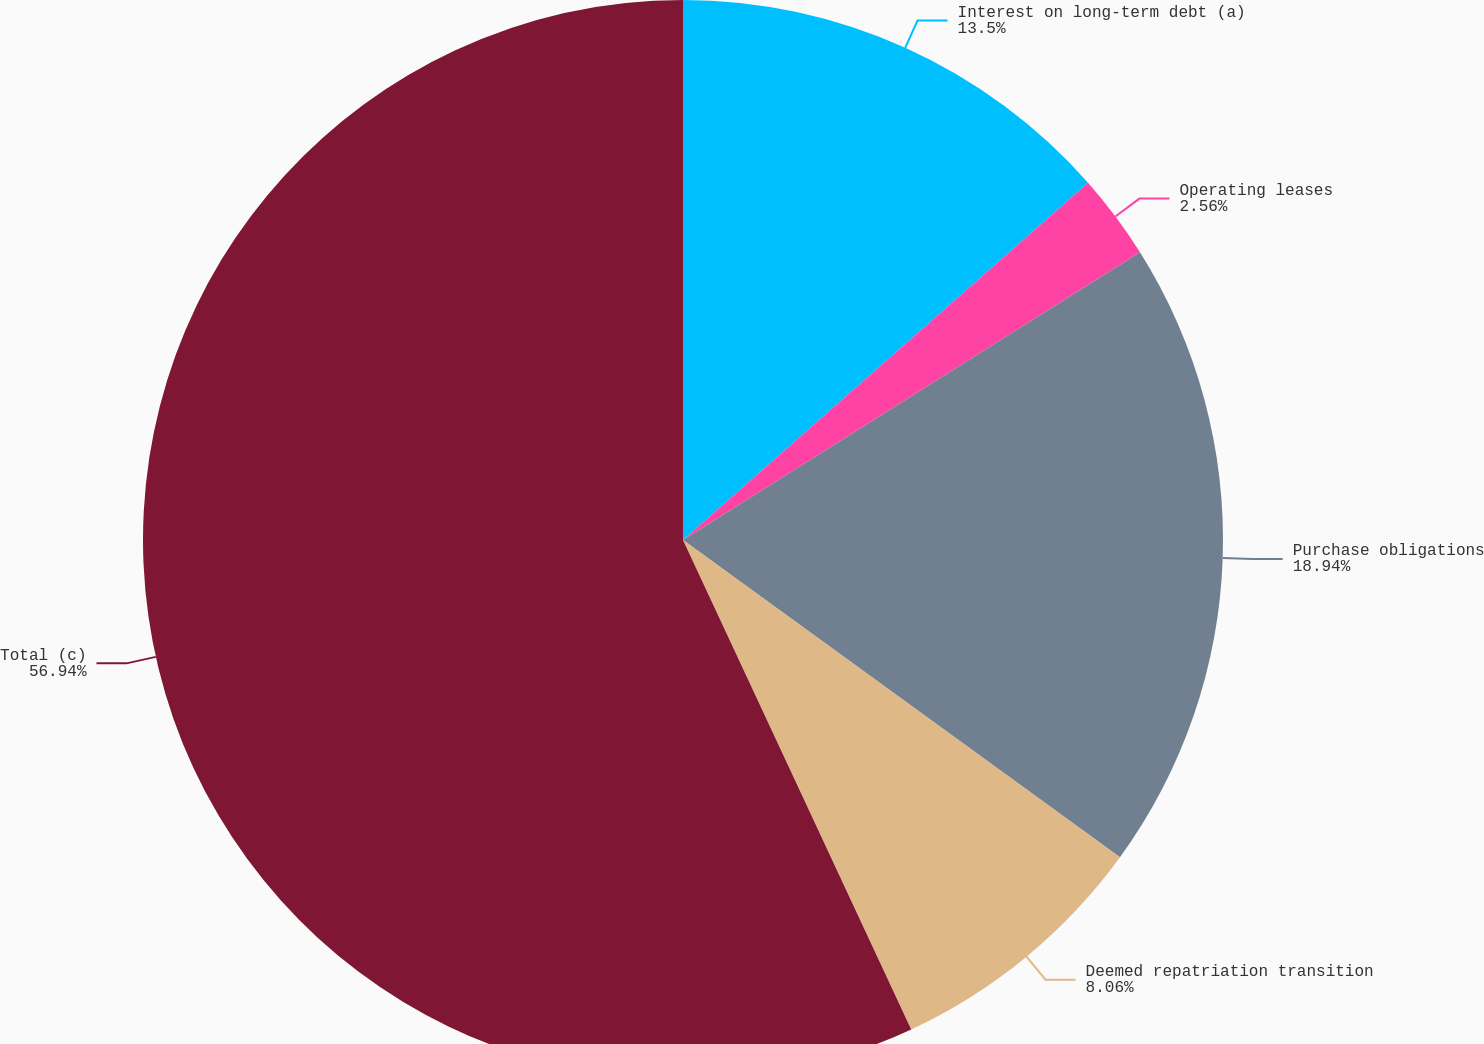Convert chart. <chart><loc_0><loc_0><loc_500><loc_500><pie_chart><fcel>Interest on long-term debt (a)<fcel>Operating leases<fcel>Purchase obligations<fcel>Deemed repatriation transition<fcel>Total (c)<nl><fcel>13.5%<fcel>2.56%<fcel>18.94%<fcel>8.06%<fcel>56.95%<nl></chart> 